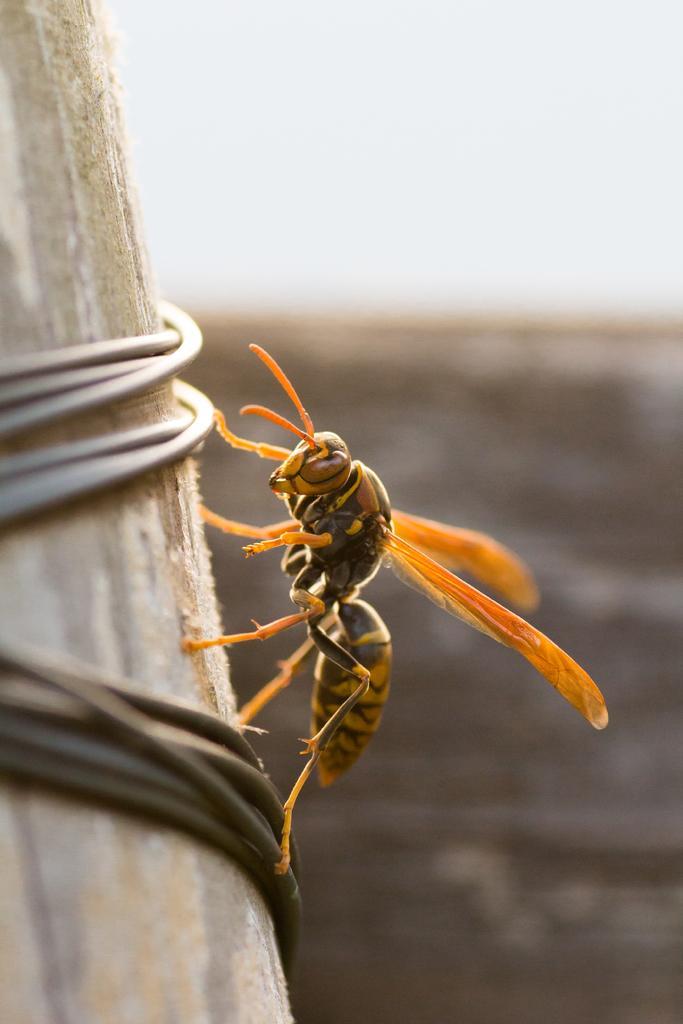In one or two sentences, can you explain what this image depicts? This picture shows a hornet on the wooden pole and we see a cloudy sky. 